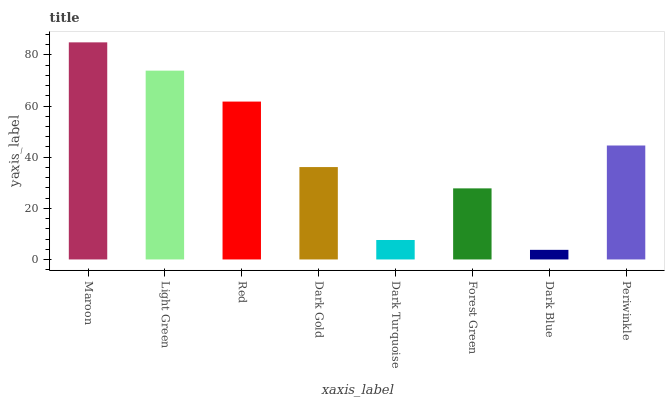Is Dark Blue the minimum?
Answer yes or no. Yes. Is Maroon the maximum?
Answer yes or no. Yes. Is Light Green the minimum?
Answer yes or no. No. Is Light Green the maximum?
Answer yes or no. No. Is Maroon greater than Light Green?
Answer yes or no. Yes. Is Light Green less than Maroon?
Answer yes or no. Yes. Is Light Green greater than Maroon?
Answer yes or no. No. Is Maroon less than Light Green?
Answer yes or no. No. Is Periwinkle the high median?
Answer yes or no. Yes. Is Dark Gold the low median?
Answer yes or no. Yes. Is Red the high median?
Answer yes or no. No. Is Red the low median?
Answer yes or no. No. 